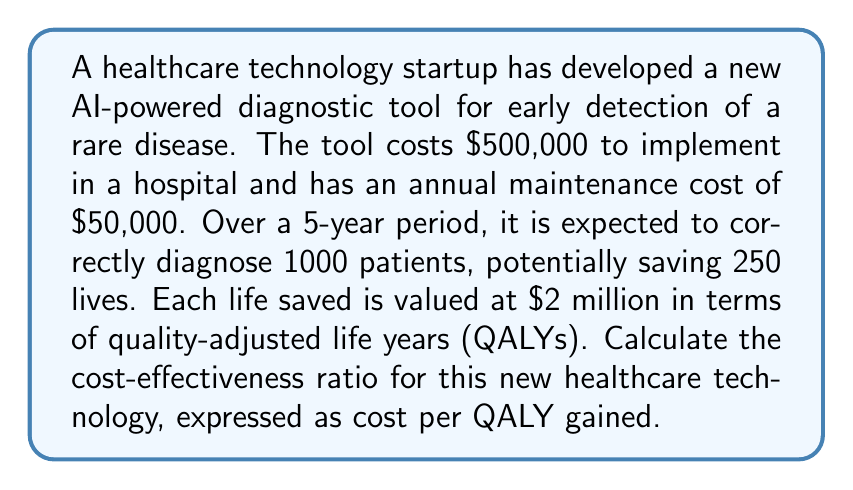Teach me how to tackle this problem. To calculate the cost-effectiveness ratio, we need to determine the total costs and total benefits over the 5-year period, then divide the costs by the benefits.

1. Calculate total costs:
   - Implementation cost: $500,000
   - Annual maintenance cost: $50,000 × 5 years = $250,000
   - Total cost = $500,000 + $250,000 = $750,000

2. Calculate total benefits:
   - Lives saved: 250
   - Value per life saved: $2 million
   - Total benefit = 250 × $2 million = $500 million

3. Convert total benefit to QALYs:
   - Since the value per life saved is already expressed in terms of QALYs, the total benefit of $500 million represents 250 QALYs.

4. Calculate the cost-effectiveness ratio:

   $$ \text{Cost-Effectiveness Ratio} = \frac{\text{Total Cost}}{\text{Total QALYs Gained}} $$

   $$ \text{Cost-Effectiveness Ratio} = \frac{\$750,000}{250 \text{ QALYs}} = \$3,000 \text{ per QALY} $$

The cost-effectiveness ratio is $3,000 per QALY gained, which means for every quality-adjusted life year gained, the technology costs $3,000.
Answer: $3,000 per QALY 